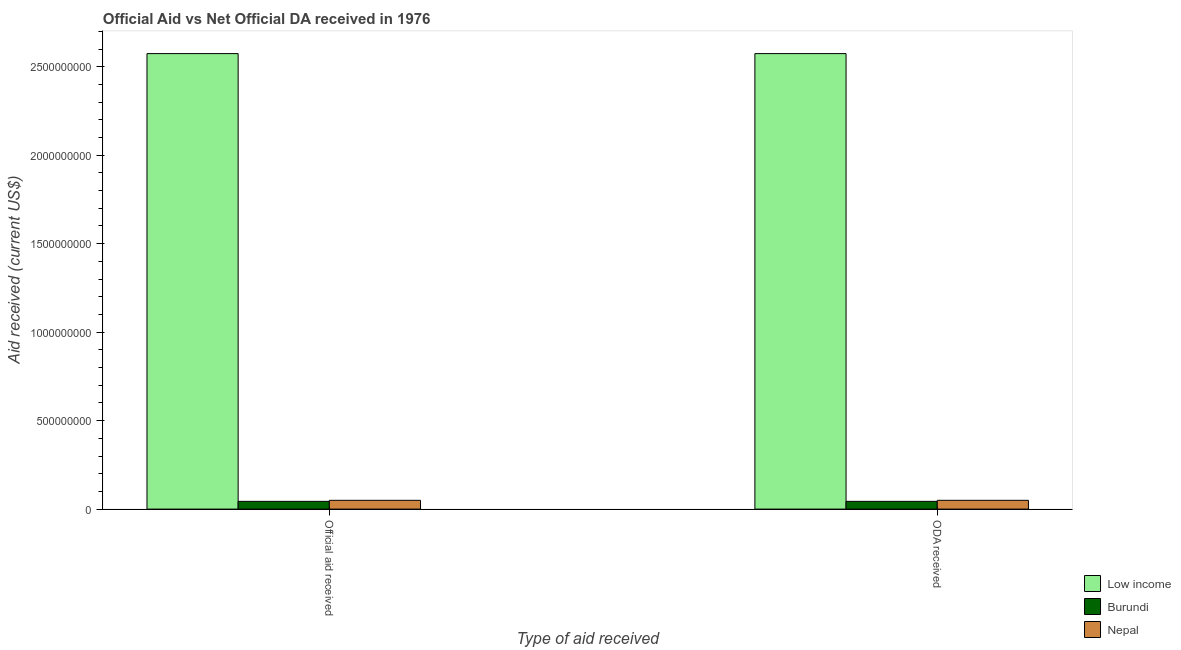How many groups of bars are there?
Your response must be concise. 2. Are the number of bars per tick equal to the number of legend labels?
Your response must be concise. Yes. Are the number of bars on each tick of the X-axis equal?
Make the answer very short. Yes. How many bars are there on the 2nd tick from the left?
Your response must be concise. 3. What is the label of the 2nd group of bars from the left?
Your answer should be very brief. ODA received. What is the oda received in Nepal?
Your answer should be compact. 4.96e+07. Across all countries, what is the maximum official aid received?
Provide a short and direct response. 2.57e+09. Across all countries, what is the minimum official aid received?
Keep it short and to the point. 4.38e+07. In which country was the official aid received maximum?
Your response must be concise. Low income. In which country was the oda received minimum?
Your answer should be compact. Burundi. What is the total official aid received in the graph?
Provide a succinct answer. 2.67e+09. What is the difference between the official aid received in Burundi and that in Nepal?
Your answer should be very brief. -5.83e+06. What is the difference between the official aid received in Burundi and the oda received in Nepal?
Keep it short and to the point. -5.83e+06. What is the average official aid received per country?
Make the answer very short. 8.89e+08. What is the difference between the official aid received and oda received in Nepal?
Ensure brevity in your answer.  0. What is the ratio of the official aid received in Nepal to that in Low income?
Your answer should be compact. 0.02. Is the oda received in Burundi less than that in Nepal?
Give a very brief answer. Yes. What does the 3rd bar from the left in ODA received represents?
Offer a terse response. Nepal. What does the 1st bar from the right in ODA received represents?
Offer a very short reply. Nepal. How many bars are there?
Your answer should be compact. 6. Are all the bars in the graph horizontal?
Offer a very short reply. No. What is the difference between two consecutive major ticks on the Y-axis?
Keep it short and to the point. 5.00e+08. Does the graph contain grids?
Keep it short and to the point. No. Where does the legend appear in the graph?
Offer a very short reply. Bottom right. How many legend labels are there?
Offer a very short reply. 3. What is the title of the graph?
Your answer should be compact. Official Aid vs Net Official DA received in 1976 . What is the label or title of the X-axis?
Give a very brief answer. Type of aid received. What is the label or title of the Y-axis?
Your answer should be very brief. Aid received (current US$). What is the Aid received (current US$) in Low income in Official aid received?
Your answer should be compact. 2.57e+09. What is the Aid received (current US$) of Burundi in Official aid received?
Your answer should be very brief. 4.38e+07. What is the Aid received (current US$) in Nepal in Official aid received?
Your answer should be very brief. 4.96e+07. What is the Aid received (current US$) in Low income in ODA received?
Your response must be concise. 2.57e+09. What is the Aid received (current US$) in Burundi in ODA received?
Your response must be concise. 4.38e+07. What is the Aid received (current US$) in Nepal in ODA received?
Keep it short and to the point. 4.96e+07. Across all Type of aid received, what is the maximum Aid received (current US$) of Low income?
Provide a succinct answer. 2.57e+09. Across all Type of aid received, what is the maximum Aid received (current US$) in Burundi?
Your answer should be compact. 4.38e+07. Across all Type of aid received, what is the maximum Aid received (current US$) of Nepal?
Make the answer very short. 4.96e+07. Across all Type of aid received, what is the minimum Aid received (current US$) in Low income?
Offer a terse response. 2.57e+09. Across all Type of aid received, what is the minimum Aid received (current US$) of Burundi?
Provide a succinct answer. 4.38e+07. Across all Type of aid received, what is the minimum Aid received (current US$) in Nepal?
Provide a succinct answer. 4.96e+07. What is the total Aid received (current US$) of Low income in the graph?
Ensure brevity in your answer.  5.15e+09. What is the total Aid received (current US$) of Burundi in the graph?
Your answer should be very brief. 8.76e+07. What is the total Aid received (current US$) in Nepal in the graph?
Make the answer very short. 9.93e+07. What is the difference between the Aid received (current US$) of Burundi in Official aid received and that in ODA received?
Keep it short and to the point. 0. What is the difference between the Aid received (current US$) of Nepal in Official aid received and that in ODA received?
Keep it short and to the point. 0. What is the difference between the Aid received (current US$) of Low income in Official aid received and the Aid received (current US$) of Burundi in ODA received?
Keep it short and to the point. 2.53e+09. What is the difference between the Aid received (current US$) of Low income in Official aid received and the Aid received (current US$) of Nepal in ODA received?
Offer a terse response. 2.52e+09. What is the difference between the Aid received (current US$) in Burundi in Official aid received and the Aid received (current US$) in Nepal in ODA received?
Provide a short and direct response. -5.83e+06. What is the average Aid received (current US$) of Low income per Type of aid received?
Provide a succinct answer. 2.57e+09. What is the average Aid received (current US$) of Burundi per Type of aid received?
Your response must be concise. 4.38e+07. What is the average Aid received (current US$) in Nepal per Type of aid received?
Keep it short and to the point. 4.96e+07. What is the difference between the Aid received (current US$) in Low income and Aid received (current US$) in Burundi in Official aid received?
Offer a terse response. 2.53e+09. What is the difference between the Aid received (current US$) in Low income and Aid received (current US$) in Nepal in Official aid received?
Offer a terse response. 2.52e+09. What is the difference between the Aid received (current US$) of Burundi and Aid received (current US$) of Nepal in Official aid received?
Provide a succinct answer. -5.83e+06. What is the difference between the Aid received (current US$) in Low income and Aid received (current US$) in Burundi in ODA received?
Your answer should be compact. 2.53e+09. What is the difference between the Aid received (current US$) of Low income and Aid received (current US$) of Nepal in ODA received?
Your answer should be very brief. 2.52e+09. What is the difference between the Aid received (current US$) of Burundi and Aid received (current US$) of Nepal in ODA received?
Offer a terse response. -5.83e+06. What is the ratio of the Aid received (current US$) in Low income in Official aid received to that in ODA received?
Your answer should be compact. 1. What is the ratio of the Aid received (current US$) in Burundi in Official aid received to that in ODA received?
Offer a very short reply. 1. What is the ratio of the Aid received (current US$) of Nepal in Official aid received to that in ODA received?
Your answer should be very brief. 1. What is the difference between the highest and the second highest Aid received (current US$) of Nepal?
Your answer should be compact. 0. What is the difference between the highest and the lowest Aid received (current US$) of Nepal?
Your answer should be very brief. 0. 